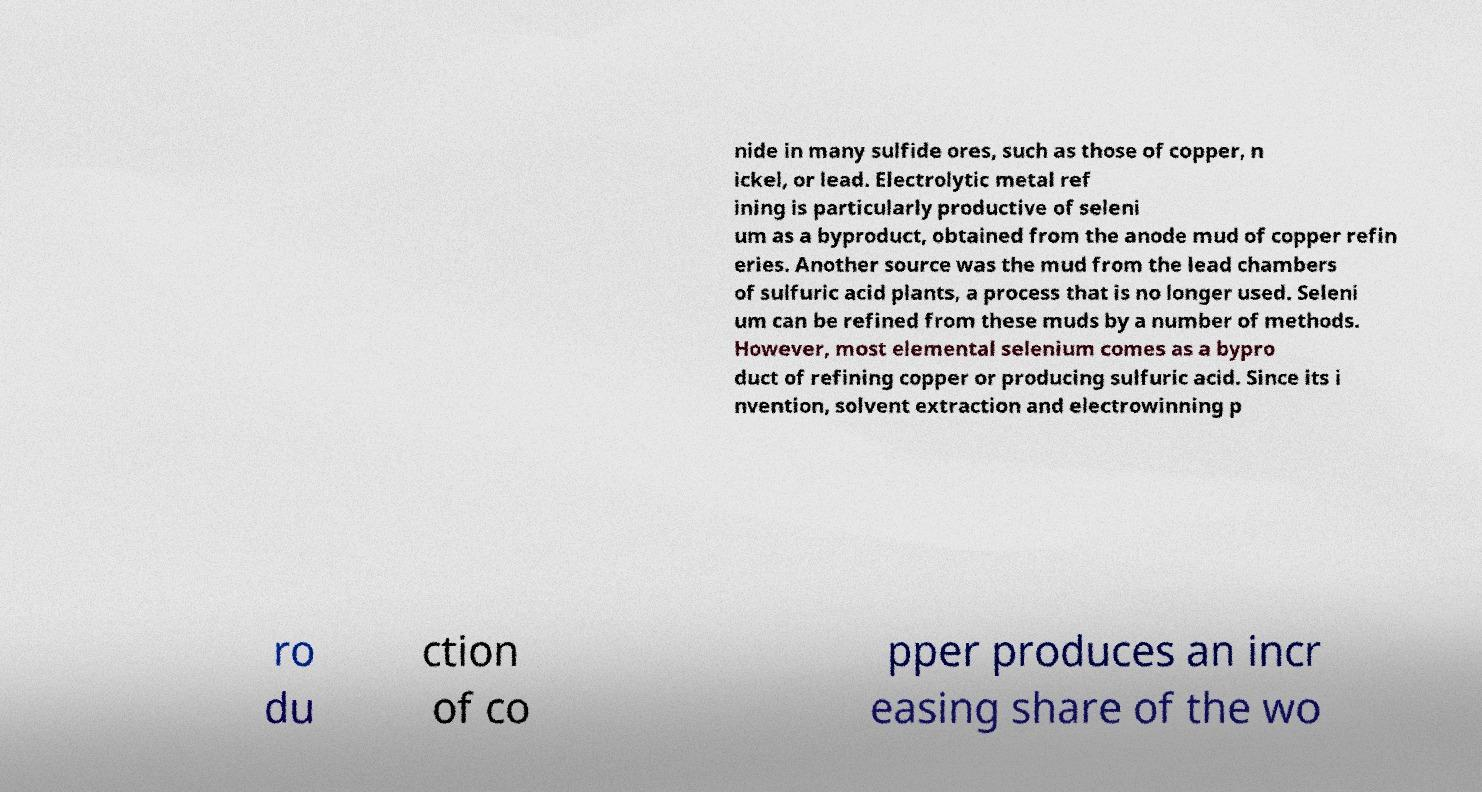Please identify and transcribe the text found in this image. nide in many sulfide ores, such as those of copper, n ickel, or lead. Electrolytic metal ref ining is particularly productive of seleni um as a byproduct, obtained from the anode mud of copper refin eries. Another source was the mud from the lead chambers of sulfuric acid plants, a process that is no longer used. Seleni um can be refined from these muds by a number of methods. However, most elemental selenium comes as a bypro duct of refining copper or producing sulfuric acid. Since its i nvention, solvent extraction and electrowinning p ro du ction of co pper produces an incr easing share of the wo 